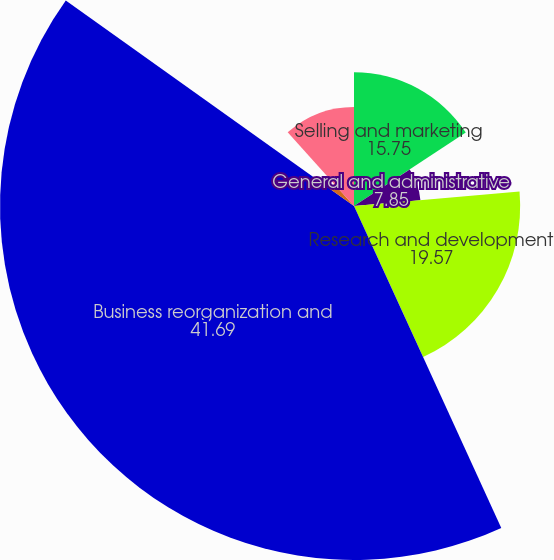Convert chart to OTSL. <chart><loc_0><loc_0><loc_500><loc_500><pie_chart><fcel>Selling and marketing<fcel>General and administrative<fcel>Research and development<fcel>Business reorganization and<fcel>Depreciation and amortization<fcel>Total operating expenses (1)<nl><fcel>15.75%<fcel>7.85%<fcel>19.57%<fcel>41.69%<fcel>3.47%<fcel>11.67%<nl></chart> 